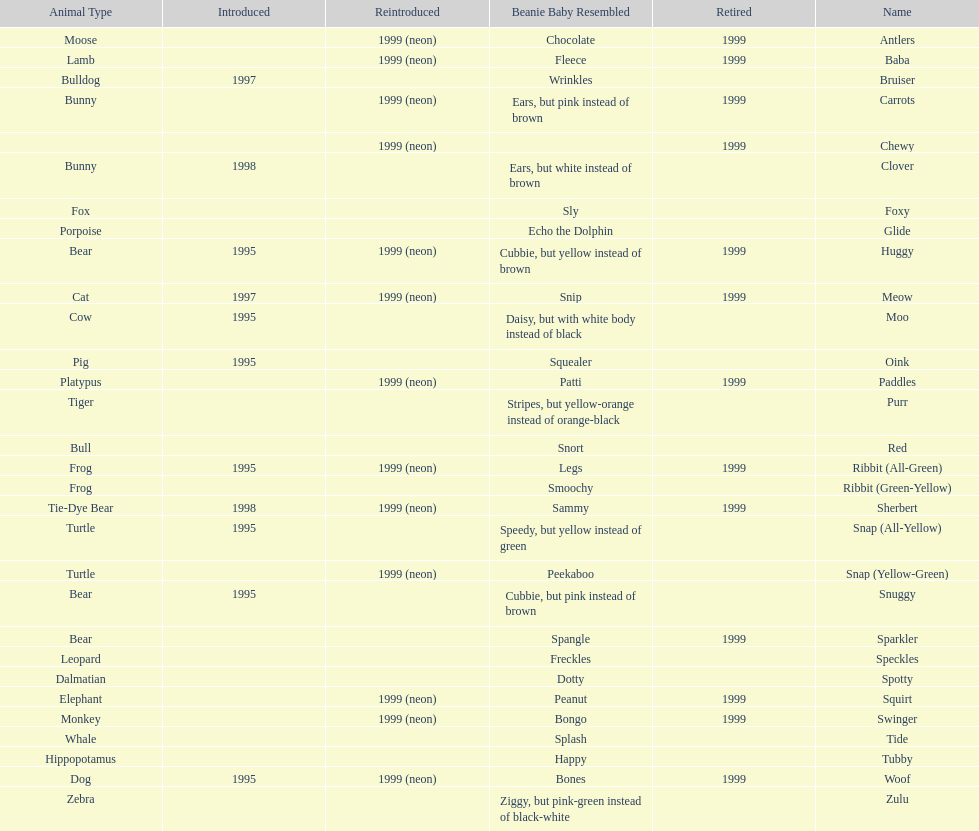Which is the only pillow pal without a listed animal type? Chewy. 